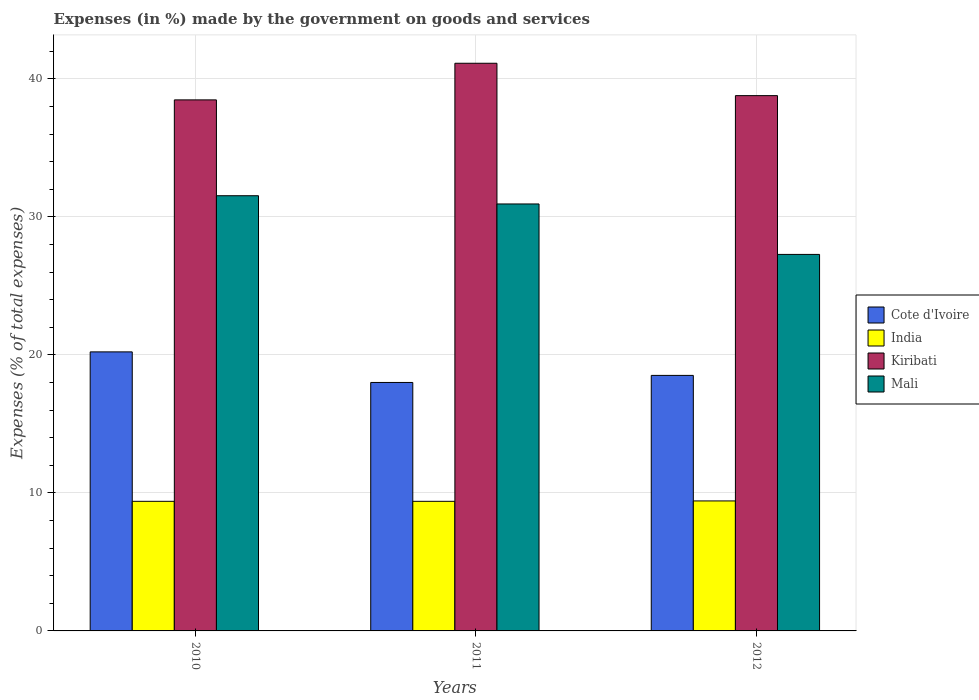How many different coloured bars are there?
Your response must be concise. 4. Are the number of bars on each tick of the X-axis equal?
Your response must be concise. Yes. How many bars are there on the 1st tick from the left?
Ensure brevity in your answer.  4. How many bars are there on the 3rd tick from the right?
Provide a succinct answer. 4. In how many cases, is the number of bars for a given year not equal to the number of legend labels?
Offer a terse response. 0. What is the percentage of expenses made by the government on goods and services in Cote d'Ivoire in 2010?
Provide a short and direct response. 20.22. Across all years, what is the maximum percentage of expenses made by the government on goods and services in Mali?
Ensure brevity in your answer.  31.54. Across all years, what is the minimum percentage of expenses made by the government on goods and services in Kiribati?
Offer a very short reply. 38.49. In which year was the percentage of expenses made by the government on goods and services in Kiribati maximum?
Give a very brief answer. 2011. What is the total percentage of expenses made by the government on goods and services in Kiribati in the graph?
Give a very brief answer. 118.42. What is the difference between the percentage of expenses made by the government on goods and services in Kiribati in 2010 and that in 2012?
Your answer should be compact. -0.31. What is the difference between the percentage of expenses made by the government on goods and services in Mali in 2010 and the percentage of expenses made by the government on goods and services in India in 2012?
Your response must be concise. 22.12. What is the average percentage of expenses made by the government on goods and services in Kiribati per year?
Your answer should be compact. 39.47. In the year 2010, what is the difference between the percentage of expenses made by the government on goods and services in Cote d'Ivoire and percentage of expenses made by the government on goods and services in Mali?
Provide a succinct answer. -11.32. In how many years, is the percentage of expenses made by the government on goods and services in India greater than 36 %?
Make the answer very short. 0. What is the ratio of the percentage of expenses made by the government on goods and services in Kiribati in 2010 to that in 2011?
Provide a short and direct response. 0.94. Is the percentage of expenses made by the government on goods and services in Kiribati in 2010 less than that in 2012?
Provide a succinct answer. Yes. What is the difference between the highest and the second highest percentage of expenses made by the government on goods and services in Kiribati?
Offer a very short reply. 2.35. What is the difference between the highest and the lowest percentage of expenses made by the government on goods and services in Cote d'Ivoire?
Offer a terse response. 2.22. Is the sum of the percentage of expenses made by the government on goods and services in Kiribati in 2011 and 2012 greater than the maximum percentage of expenses made by the government on goods and services in Mali across all years?
Ensure brevity in your answer.  Yes. Is it the case that in every year, the sum of the percentage of expenses made by the government on goods and services in Mali and percentage of expenses made by the government on goods and services in Kiribati is greater than the sum of percentage of expenses made by the government on goods and services in Cote d'Ivoire and percentage of expenses made by the government on goods and services in India?
Your response must be concise. Yes. What does the 2nd bar from the right in 2010 represents?
Provide a succinct answer. Kiribati. How many years are there in the graph?
Your answer should be compact. 3. What is the difference between two consecutive major ticks on the Y-axis?
Ensure brevity in your answer.  10. Does the graph contain any zero values?
Offer a very short reply. No. Does the graph contain grids?
Provide a succinct answer. Yes. Where does the legend appear in the graph?
Your answer should be compact. Center right. How many legend labels are there?
Offer a very short reply. 4. How are the legend labels stacked?
Provide a succinct answer. Vertical. What is the title of the graph?
Offer a very short reply. Expenses (in %) made by the government on goods and services. Does "Bangladesh" appear as one of the legend labels in the graph?
Your answer should be compact. No. What is the label or title of the Y-axis?
Provide a succinct answer. Expenses (% of total expenses). What is the Expenses (% of total expenses) in Cote d'Ivoire in 2010?
Keep it short and to the point. 20.22. What is the Expenses (% of total expenses) of India in 2010?
Your response must be concise. 9.39. What is the Expenses (% of total expenses) of Kiribati in 2010?
Ensure brevity in your answer.  38.49. What is the Expenses (% of total expenses) of Mali in 2010?
Your answer should be compact. 31.54. What is the Expenses (% of total expenses) in Cote d'Ivoire in 2011?
Your response must be concise. 18.01. What is the Expenses (% of total expenses) in India in 2011?
Your answer should be compact. 9.39. What is the Expenses (% of total expenses) of Kiribati in 2011?
Provide a succinct answer. 41.14. What is the Expenses (% of total expenses) in Mali in 2011?
Offer a terse response. 30.94. What is the Expenses (% of total expenses) in Cote d'Ivoire in 2012?
Make the answer very short. 18.52. What is the Expenses (% of total expenses) of India in 2012?
Keep it short and to the point. 9.42. What is the Expenses (% of total expenses) in Kiribati in 2012?
Offer a very short reply. 38.79. What is the Expenses (% of total expenses) in Mali in 2012?
Provide a short and direct response. 27.29. Across all years, what is the maximum Expenses (% of total expenses) in Cote d'Ivoire?
Offer a very short reply. 20.22. Across all years, what is the maximum Expenses (% of total expenses) in India?
Offer a very short reply. 9.42. Across all years, what is the maximum Expenses (% of total expenses) of Kiribati?
Your answer should be very brief. 41.14. Across all years, what is the maximum Expenses (% of total expenses) of Mali?
Your response must be concise. 31.54. Across all years, what is the minimum Expenses (% of total expenses) in Cote d'Ivoire?
Your answer should be compact. 18.01. Across all years, what is the minimum Expenses (% of total expenses) in India?
Your answer should be compact. 9.39. Across all years, what is the minimum Expenses (% of total expenses) in Kiribati?
Offer a very short reply. 38.49. Across all years, what is the minimum Expenses (% of total expenses) of Mali?
Offer a very short reply. 27.29. What is the total Expenses (% of total expenses) in Cote d'Ivoire in the graph?
Make the answer very short. 56.75. What is the total Expenses (% of total expenses) in India in the graph?
Provide a succinct answer. 28.2. What is the total Expenses (% of total expenses) in Kiribati in the graph?
Give a very brief answer. 118.42. What is the total Expenses (% of total expenses) of Mali in the graph?
Provide a succinct answer. 89.77. What is the difference between the Expenses (% of total expenses) in Cote d'Ivoire in 2010 and that in 2011?
Ensure brevity in your answer.  2.22. What is the difference between the Expenses (% of total expenses) of India in 2010 and that in 2011?
Your response must be concise. 0. What is the difference between the Expenses (% of total expenses) in Kiribati in 2010 and that in 2011?
Your answer should be compact. -2.65. What is the difference between the Expenses (% of total expenses) of Mali in 2010 and that in 2011?
Your answer should be compact. 0.6. What is the difference between the Expenses (% of total expenses) of Cote d'Ivoire in 2010 and that in 2012?
Offer a terse response. 1.71. What is the difference between the Expenses (% of total expenses) in India in 2010 and that in 2012?
Ensure brevity in your answer.  -0.03. What is the difference between the Expenses (% of total expenses) of Kiribati in 2010 and that in 2012?
Provide a short and direct response. -0.31. What is the difference between the Expenses (% of total expenses) of Mali in 2010 and that in 2012?
Provide a short and direct response. 4.25. What is the difference between the Expenses (% of total expenses) of Cote d'Ivoire in 2011 and that in 2012?
Your answer should be compact. -0.51. What is the difference between the Expenses (% of total expenses) in India in 2011 and that in 2012?
Offer a terse response. -0.03. What is the difference between the Expenses (% of total expenses) in Kiribati in 2011 and that in 2012?
Give a very brief answer. 2.35. What is the difference between the Expenses (% of total expenses) of Mali in 2011 and that in 2012?
Give a very brief answer. 3.66. What is the difference between the Expenses (% of total expenses) of Cote d'Ivoire in 2010 and the Expenses (% of total expenses) of India in 2011?
Make the answer very short. 10.83. What is the difference between the Expenses (% of total expenses) in Cote d'Ivoire in 2010 and the Expenses (% of total expenses) in Kiribati in 2011?
Provide a succinct answer. -20.92. What is the difference between the Expenses (% of total expenses) of Cote d'Ivoire in 2010 and the Expenses (% of total expenses) of Mali in 2011?
Offer a very short reply. -10.72. What is the difference between the Expenses (% of total expenses) of India in 2010 and the Expenses (% of total expenses) of Kiribati in 2011?
Offer a very short reply. -31.75. What is the difference between the Expenses (% of total expenses) in India in 2010 and the Expenses (% of total expenses) in Mali in 2011?
Ensure brevity in your answer.  -21.55. What is the difference between the Expenses (% of total expenses) of Kiribati in 2010 and the Expenses (% of total expenses) of Mali in 2011?
Ensure brevity in your answer.  7.54. What is the difference between the Expenses (% of total expenses) in Cote d'Ivoire in 2010 and the Expenses (% of total expenses) in India in 2012?
Make the answer very short. 10.8. What is the difference between the Expenses (% of total expenses) in Cote d'Ivoire in 2010 and the Expenses (% of total expenses) in Kiribati in 2012?
Your answer should be very brief. -18.57. What is the difference between the Expenses (% of total expenses) in Cote d'Ivoire in 2010 and the Expenses (% of total expenses) in Mali in 2012?
Provide a short and direct response. -7.06. What is the difference between the Expenses (% of total expenses) in India in 2010 and the Expenses (% of total expenses) in Kiribati in 2012?
Make the answer very short. -29.4. What is the difference between the Expenses (% of total expenses) of India in 2010 and the Expenses (% of total expenses) of Mali in 2012?
Your answer should be compact. -17.89. What is the difference between the Expenses (% of total expenses) in Kiribati in 2010 and the Expenses (% of total expenses) in Mali in 2012?
Keep it short and to the point. 11.2. What is the difference between the Expenses (% of total expenses) in Cote d'Ivoire in 2011 and the Expenses (% of total expenses) in India in 2012?
Your answer should be compact. 8.59. What is the difference between the Expenses (% of total expenses) of Cote d'Ivoire in 2011 and the Expenses (% of total expenses) of Kiribati in 2012?
Provide a short and direct response. -20.79. What is the difference between the Expenses (% of total expenses) in Cote d'Ivoire in 2011 and the Expenses (% of total expenses) in Mali in 2012?
Give a very brief answer. -9.28. What is the difference between the Expenses (% of total expenses) in India in 2011 and the Expenses (% of total expenses) in Kiribati in 2012?
Ensure brevity in your answer.  -29.4. What is the difference between the Expenses (% of total expenses) of India in 2011 and the Expenses (% of total expenses) of Mali in 2012?
Keep it short and to the point. -17.89. What is the difference between the Expenses (% of total expenses) of Kiribati in 2011 and the Expenses (% of total expenses) of Mali in 2012?
Keep it short and to the point. 13.85. What is the average Expenses (% of total expenses) in Cote d'Ivoire per year?
Provide a succinct answer. 18.92. What is the average Expenses (% of total expenses) of India per year?
Make the answer very short. 9.4. What is the average Expenses (% of total expenses) of Kiribati per year?
Provide a short and direct response. 39.47. What is the average Expenses (% of total expenses) in Mali per year?
Offer a very short reply. 29.92. In the year 2010, what is the difference between the Expenses (% of total expenses) of Cote d'Ivoire and Expenses (% of total expenses) of India?
Your answer should be compact. 10.83. In the year 2010, what is the difference between the Expenses (% of total expenses) of Cote d'Ivoire and Expenses (% of total expenses) of Kiribati?
Provide a short and direct response. -18.26. In the year 2010, what is the difference between the Expenses (% of total expenses) in Cote d'Ivoire and Expenses (% of total expenses) in Mali?
Your answer should be very brief. -11.32. In the year 2010, what is the difference between the Expenses (% of total expenses) of India and Expenses (% of total expenses) of Kiribati?
Make the answer very short. -29.09. In the year 2010, what is the difference between the Expenses (% of total expenses) in India and Expenses (% of total expenses) in Mali?
Give a very brief answer. -22.15. In the year 2010, what is the difference between the Expenses (% of total expenses) of Kiribati and Expenses (% of total expenses) of Mali?
Your response must be concise. 6.95. In the year 2011, what is the difference between the Expenses (% of total expenses) in Cote d'Ivoire and Expenses (% of total expenses) in India?
Provide a short and direct response. 8.61. In the year 2011, what is the difference between the Expenses (% of total expenses) in Cote d'Ivoire and Expenses (% of total expenses) in Kiribati?
Keep it short and to the point. -23.13. In the year 2011, what is the difference between the Expenses (% of total expenses) of Cote d'Ivoire and Expenses (% of total expenses) of Mali?
Your response must be concise. -12.94. In the year 2011, what is the difference between the Expenses (% of total expenses) in India and Expenses (% of total expenses) in Kiribati?
Make the answer very short. -31.75. In the year 2011, what is the difference between the Expenses (% of total expenses) in India and Expenses (% of total expenses) in Mali?
Ensure brevity in your answer.  -21.55. In the year 2011, what is the difference between the Expenses (% of total expenses) of Kiribati and Expenses (% of total expenses) of Mali?
Provide a short and direct response. 10.2. In the year 2012, what is the difference between the Expenses (% of total expenses) of Cote d'Ivoire and Expenses (% of total expenses) of India?
Your answer should be compact. 9.1. In the year 2012, what is the difference between the Expenses (% of total expenses) of Cote d'Ivoire and Expenses (% of total expenses) of Kiribati?
Make the answer very short. -20.28. In the year 2012, what is the difference between the Expenses (% of total expenses) in Cote d'Ivoire and Expenses (% of total expenses) in Mali?
Keep it short and to the point. -8.77. In the year 2012, what is the difference between the Expenses (% of total expenses) in India and Expenses (% of total expenses) in Kiribati?
Offer a terse response. -29.37. In the year 2012, what is the difference between the Expenses (% of total expenses) in India and Expenses (% of total expenses) in Mali?
Your response must be concise. -17.87. In the year 2012, what is the difference between the Expenses (% of total expenses) of Kiribati and Expenses (% of total expenses) of Mali?
Your response must be concise. 11.51. What is the ratio of the Expenses (% of total expenses) in Cote d'Ivoire in 2010 to that in 2011?
Your answer should be compact. 1.12. What is the ratio of the Expenses (% of total expenses) in India in 2010 to that in 2011?
Offer a very short reply. 1. What is the ratio of the Expenses (% of total expenses) of Kiribati in 2010 to that in 2011?
Make the answer very short. 0.94. What is the ratio of the Expenses (% of total expenses) in Mali in 2010 to that in 2011?
Keep it short and to the point. 1.02. What is the ratio of the Expenses (% of total expenses) in Cote d'Ivoire in 2010 to that in 2012?
Your response must be concise. 1.09. What is the ratio of the Expenses (% of total expenses) in India in 2010 to that in 2012?
Ensure brevity in your answer.  1. What is the ratio of the Expenses (% of total expenses) of Mali in 2010 to that in 2012?
Offer a terse response. 1.16. What is the ratio of the Expenses (% of total expenses) in Cote d'Ivoire in 2011 to that in 2012?
Keep it short and to the point. 0.97. What is the ratio of the Expenses (% of total expenses) of India in 2011 to that in 2012?
Offer a very short reply. 1. What is the ratio of the Expenses (% of total expenses) in Kiribati in 2011 to that in 2012?
Ensure brevity in your answer.  1.06. What is the ratio of the Expenses (% of total expenses) in Mali in 2011 to that in 2012?
Ensure brevity in your answer.  1.13. What is the difference between the highest and the second highest Expenses (% of total expenses) of Cote d'Ivoire?
Provide a succinct answer. 1.71. What is the difference between the highest and the second highest Expenses (% of total expenses) in India?
Offer a very short reply. 0.03. What is the difference between the highest and the second highest Expenses (% of total expenses) in Kiribati?
Offer a very short reply. 2.35. What is the difference between the highest and the second highest Expenses (% of total expenses) of Mali?
Offer a terse response. 0.6. What is the difference between the highest and the lowest Expenses (% of total expenses) in Cote d'Ivoire?
Provide a short and direct response. 2.22. What is the difference between the highest and the lowest Expenses (% of total expenses) in India?
Your answer should be compact. 0.03. What is the difference between the highest and the lowest Expenses (% of total expenses) of Kiribati?
Your answer should be very brief. 2.65. What is the difference between the highest and the lowest Expenses (% of total expenses) of Mali?
Give a very brief answer. 4.25. 